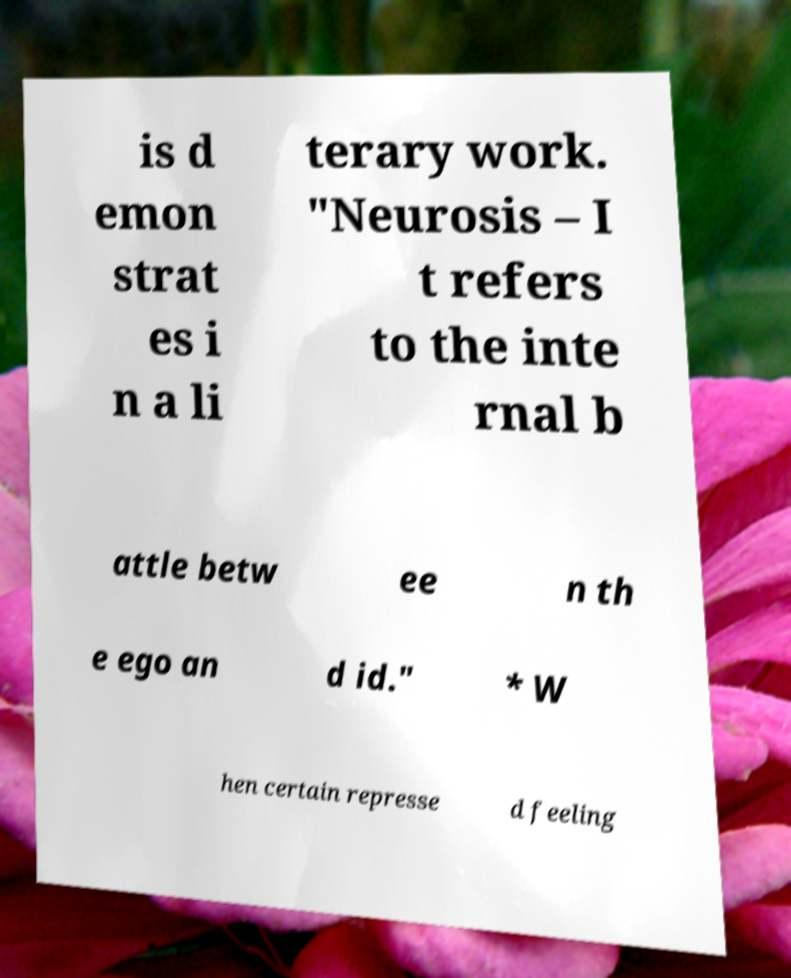Could you assist in decoding the text presented in this image and type it out clearly? is d emon strat es i n a li terary work. "Neurosis – I t refers to the inte rnal b attle betw ee n th e ego an d id." * W hen certain represse d feeling 